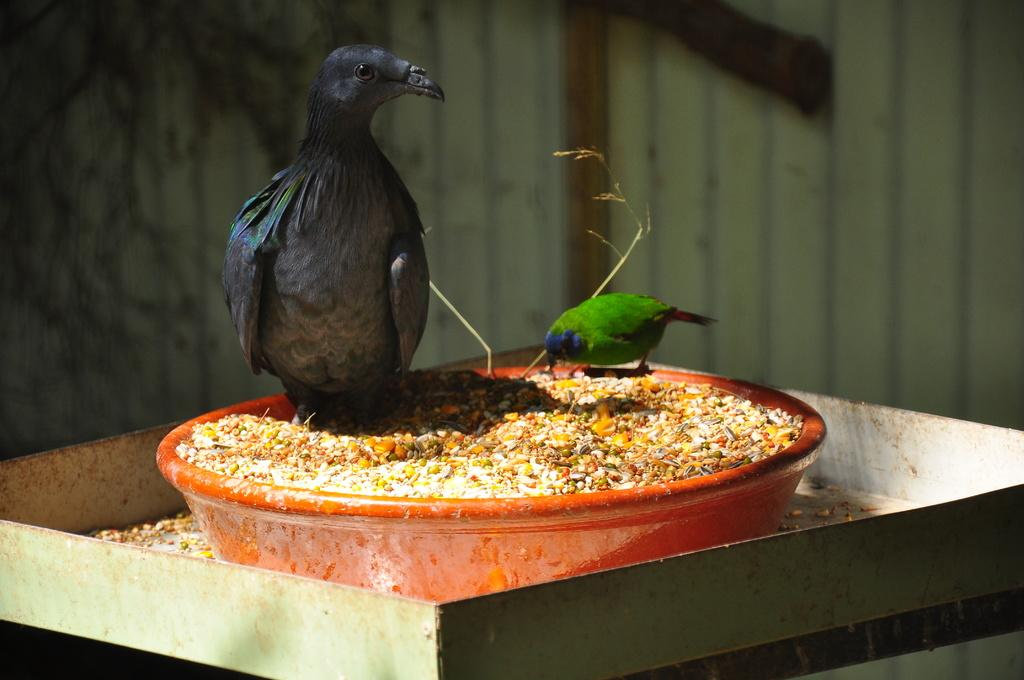How many birds are present in the image? There are two birds in the image. What are the birds standing on? The birds are standing on a bowl. What is inside the bowl that the birds are standing on? The bowl is filled with grains. What can be seen on the roof in the image? Sunlight is falling on the roof in the image. What type of stitch is being used to sew the birds' wings together in the image? There is no indication in the image that the birds' wings are being sewn together, nor is there any mention of a stitch. 